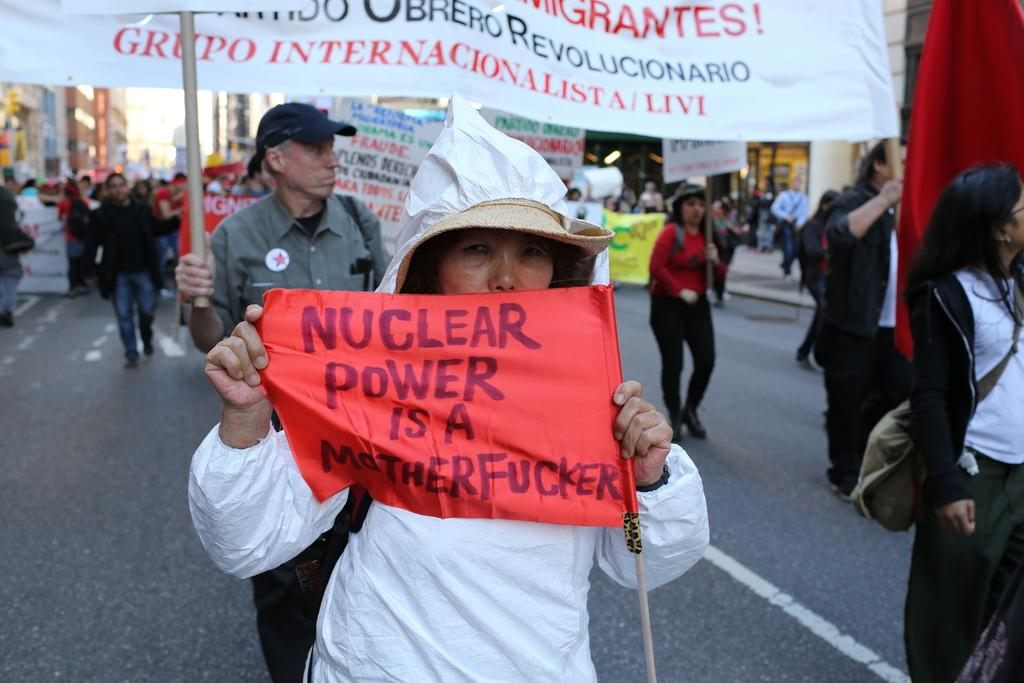Who or what is present in the image? There are people in the image. What are the people wearing? The people are wearing bags. What are the people holding in the image? The people are holding banners. What can be read on the banners? There is text written on the banners. What can be seen in the distance in the image? There are buildings in the background of the image. How many sons are visible in the image? There is no mention of sons in the image; the people are holding banners. 